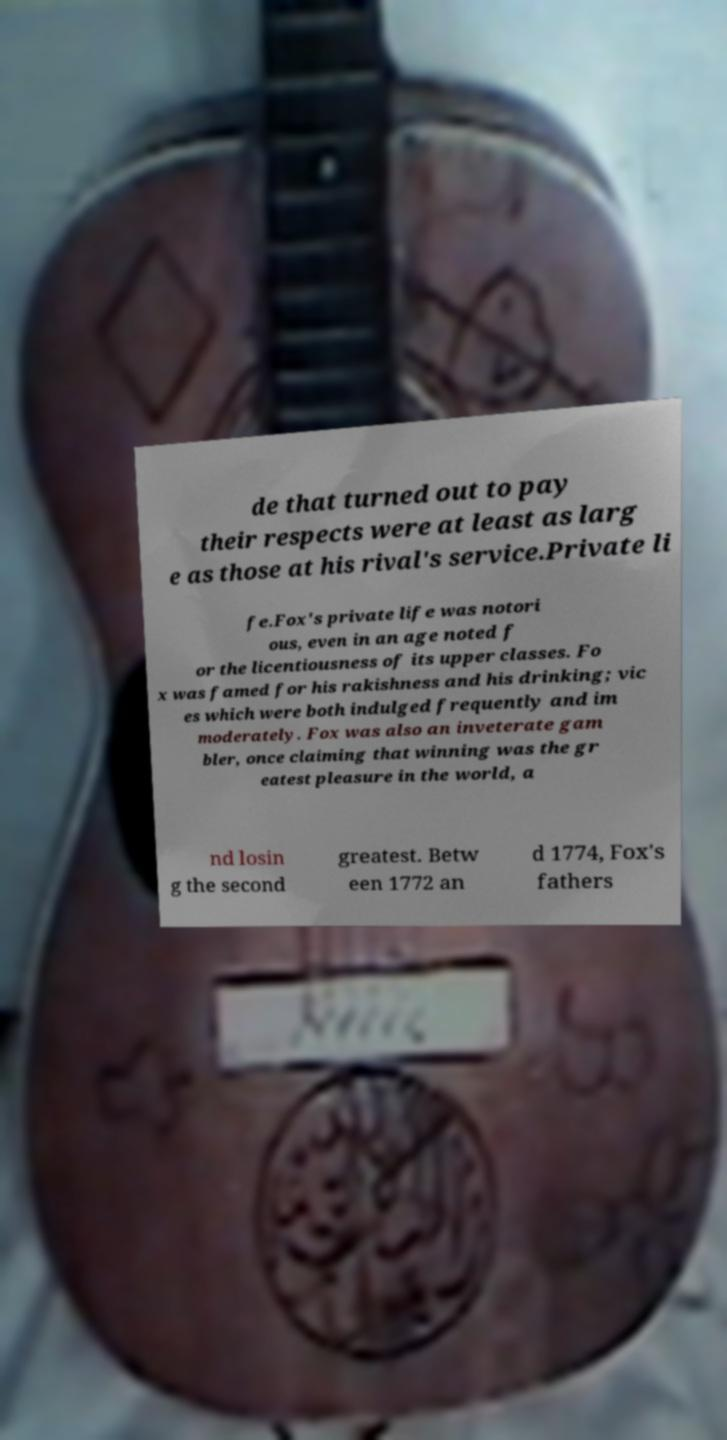What messages or text are displayed in this image? I need them in a readable, typed format. de that turned out to pay their respects were at least as larg e as those at his rival's service.Private li fe.Fox's private life was notori ous, even in an age noted f or the licentiousness of its upper classes. Fo x was famed for his rakishness and his drinking; vic es which were both indulged frequently and im moderately. Fox was also an inveterate gam bler, once claiming that winning was the gr eatest pleasure in the world, a nd losin g the second greatest. Betw een 1772 an d 1774, Fox's fathers 